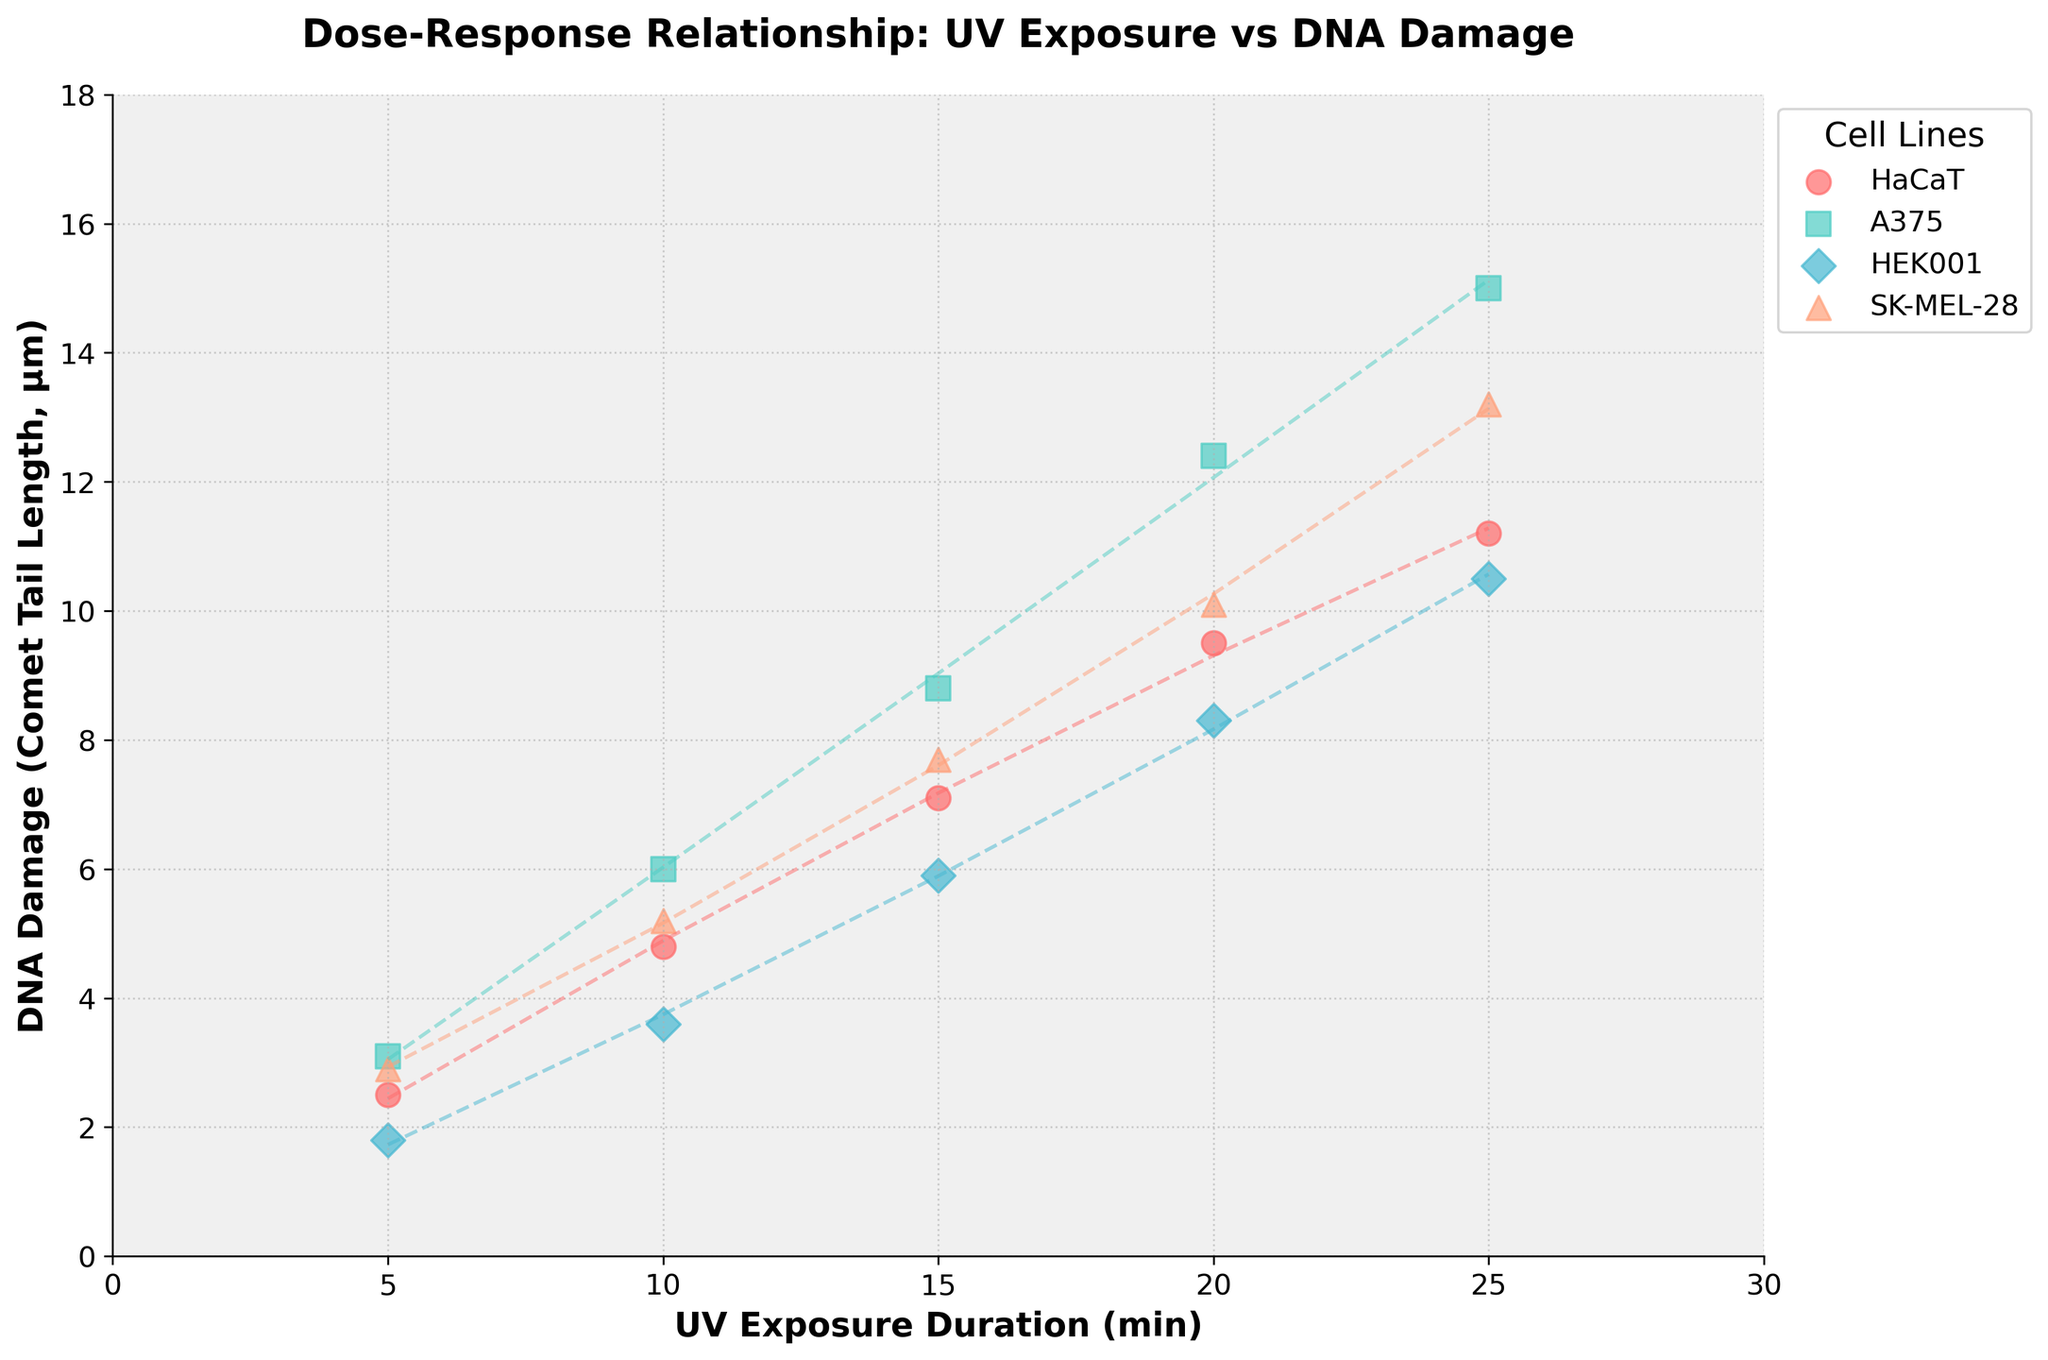What's the title of the figure? The title is located at the top center of the figure in bold font.
Answer: Dose-Response Relationship: UV Exposure vs DNA Damage How many different cell lines are represented in the figure? Count the number of unique cell lines listed in the legend to the right of the plot.
Answer: Four What is the range of UV exposure duration on the x-axis? The x-axis has labels indicating the range of UV exposure duration.
Answer: 0 to 30 minutes Which cell line shows the highest DNA damage at 25 minutes of UV exposure? Look at the data points corresponding to 25 minutes on the x-axis and compare the y-values.
Answer: A375 What's the trend for DNA damage in HaCaT cells as UV exposure duration increases? Observe the data points and the dashed trend line for HaCaT cells.
Answer: It increases Which cell line shows the least DNA damage at 5 minutes of UV exposure? Look at the data points corresponding to 5 minutes on the x-axis and compare the y-values.
Answer: HEK001 For the A375 cell line, what is the difference in DNA damage between 15 minutes and 20 minutes of UV exposure? Subtract the DNA damage value at 15 minutes from the value at 20 minutes for A375 cells.
Answer: 3.6 µm Is there a cell line for which the DNA damage appears to fit a quadratic trend across the UV exposure durations? Look for data points and trend lines resembling a quadratic fit.
Answer: Yes, all cell lines show a quadratic trend Which cell line has the steepest increase in DNA damage as UV exposure duration increases from 10 to 20 minutes? Compare the slopes of the trend lines between 10 and 20 minutes for all cell lines.
Answer: A375 